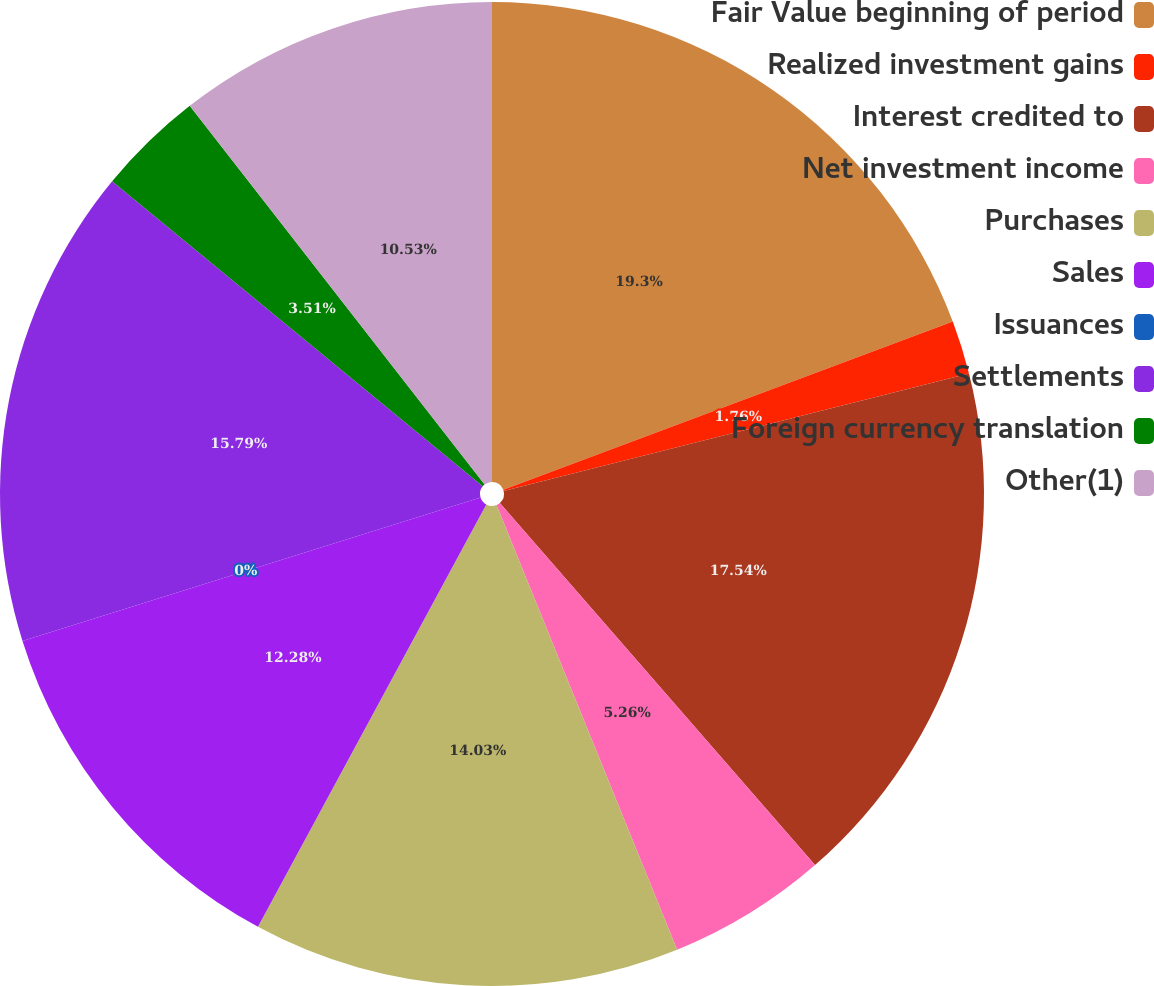Convert chart. <chart><loc_0><loc_0><loc_500><loc_500><pie_chart><fcel>Fair Value beginning of period<fcel>Realized investment gains<fcel>Interest credited to<fcel>Net investment income<fcel>Purchases<fcel>Sales<fcel>Issuances<fcel>Settlements<fcel>Foreign currency translation<fcel>Other(1)<nl><fcel>19.3%<fcel>1.76%<fcel>17.54%<fcel>5.26%<fcel>14.03%<fcel>12.28%<fcel>0.0%<fcel>15.79%<fcel>3.51%<fcel>10.53%<nl></chart> 